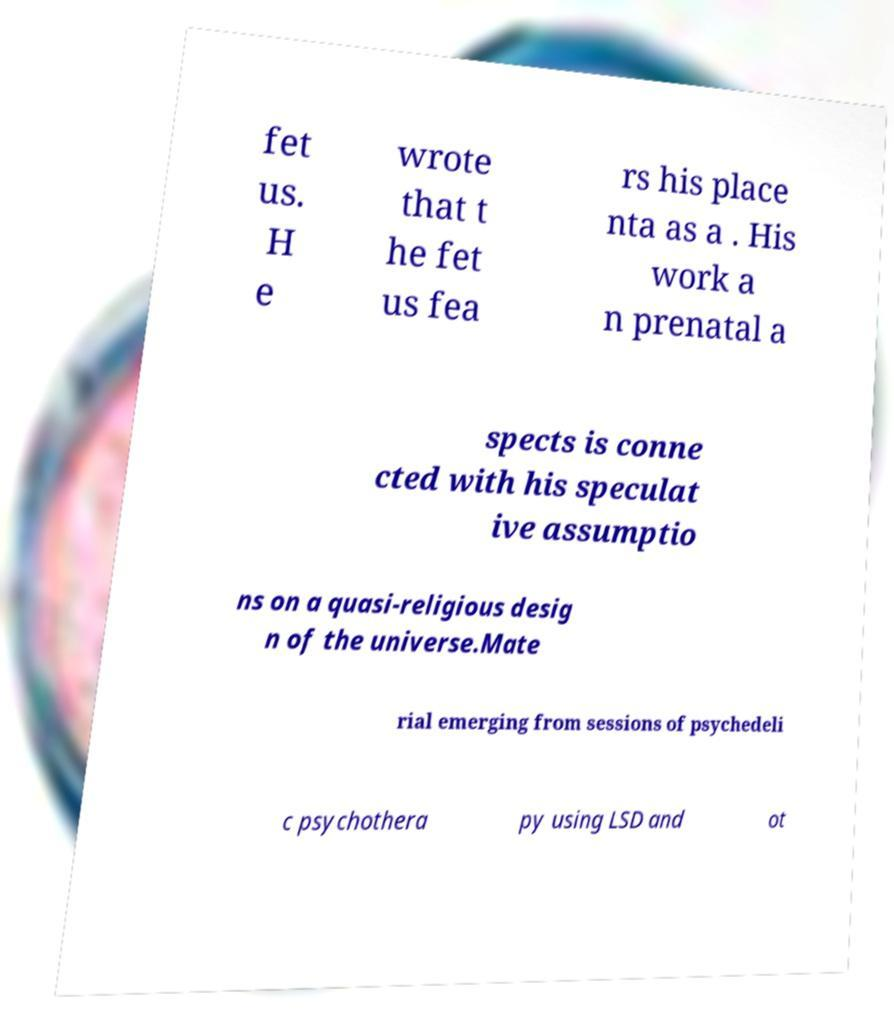Can you accurately transcribe the text from the provided image for me? fet us. H e wrote that t he fet us fea rs his place nta as a . His work a n prenatal a spects is conne cted with his speculat ive assumptio ns on a quasi-religious desig n of the universe.Mate rial emerging from sessions of psychedeli c psychothera py using LSD and ot 